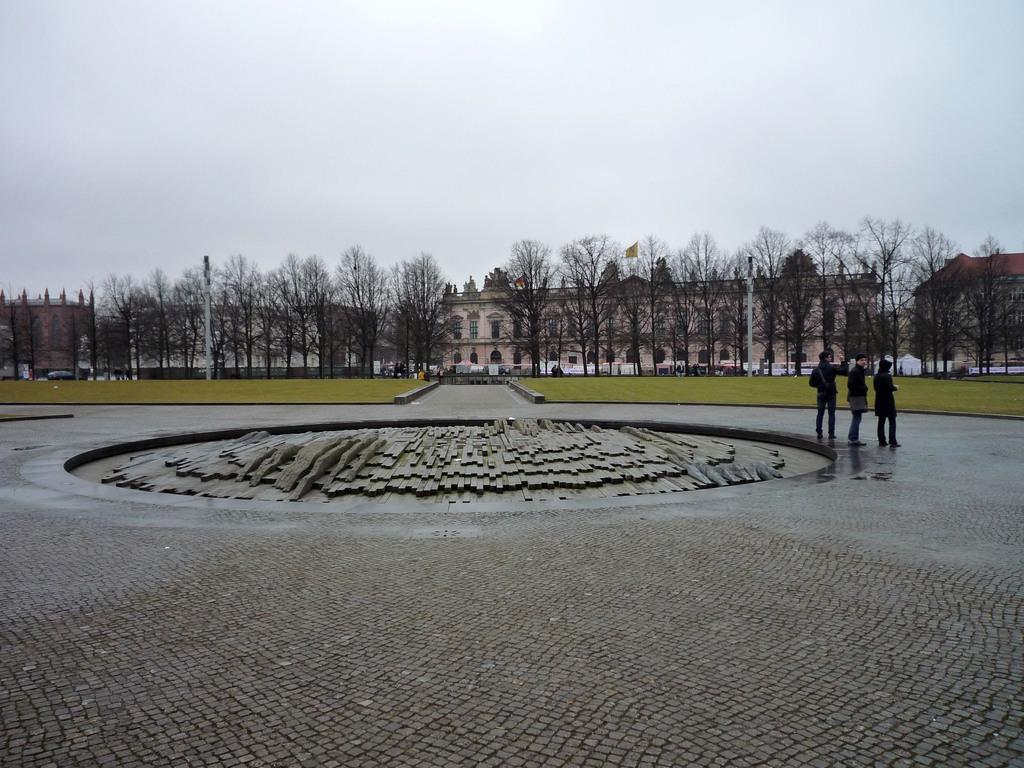In one or two sentences, can you explain what this image depicts? In this image we can see three people standing on the road. In the middle of the image there is a ground with trees, behind this there is a building. In the background of the image there is a sky. 